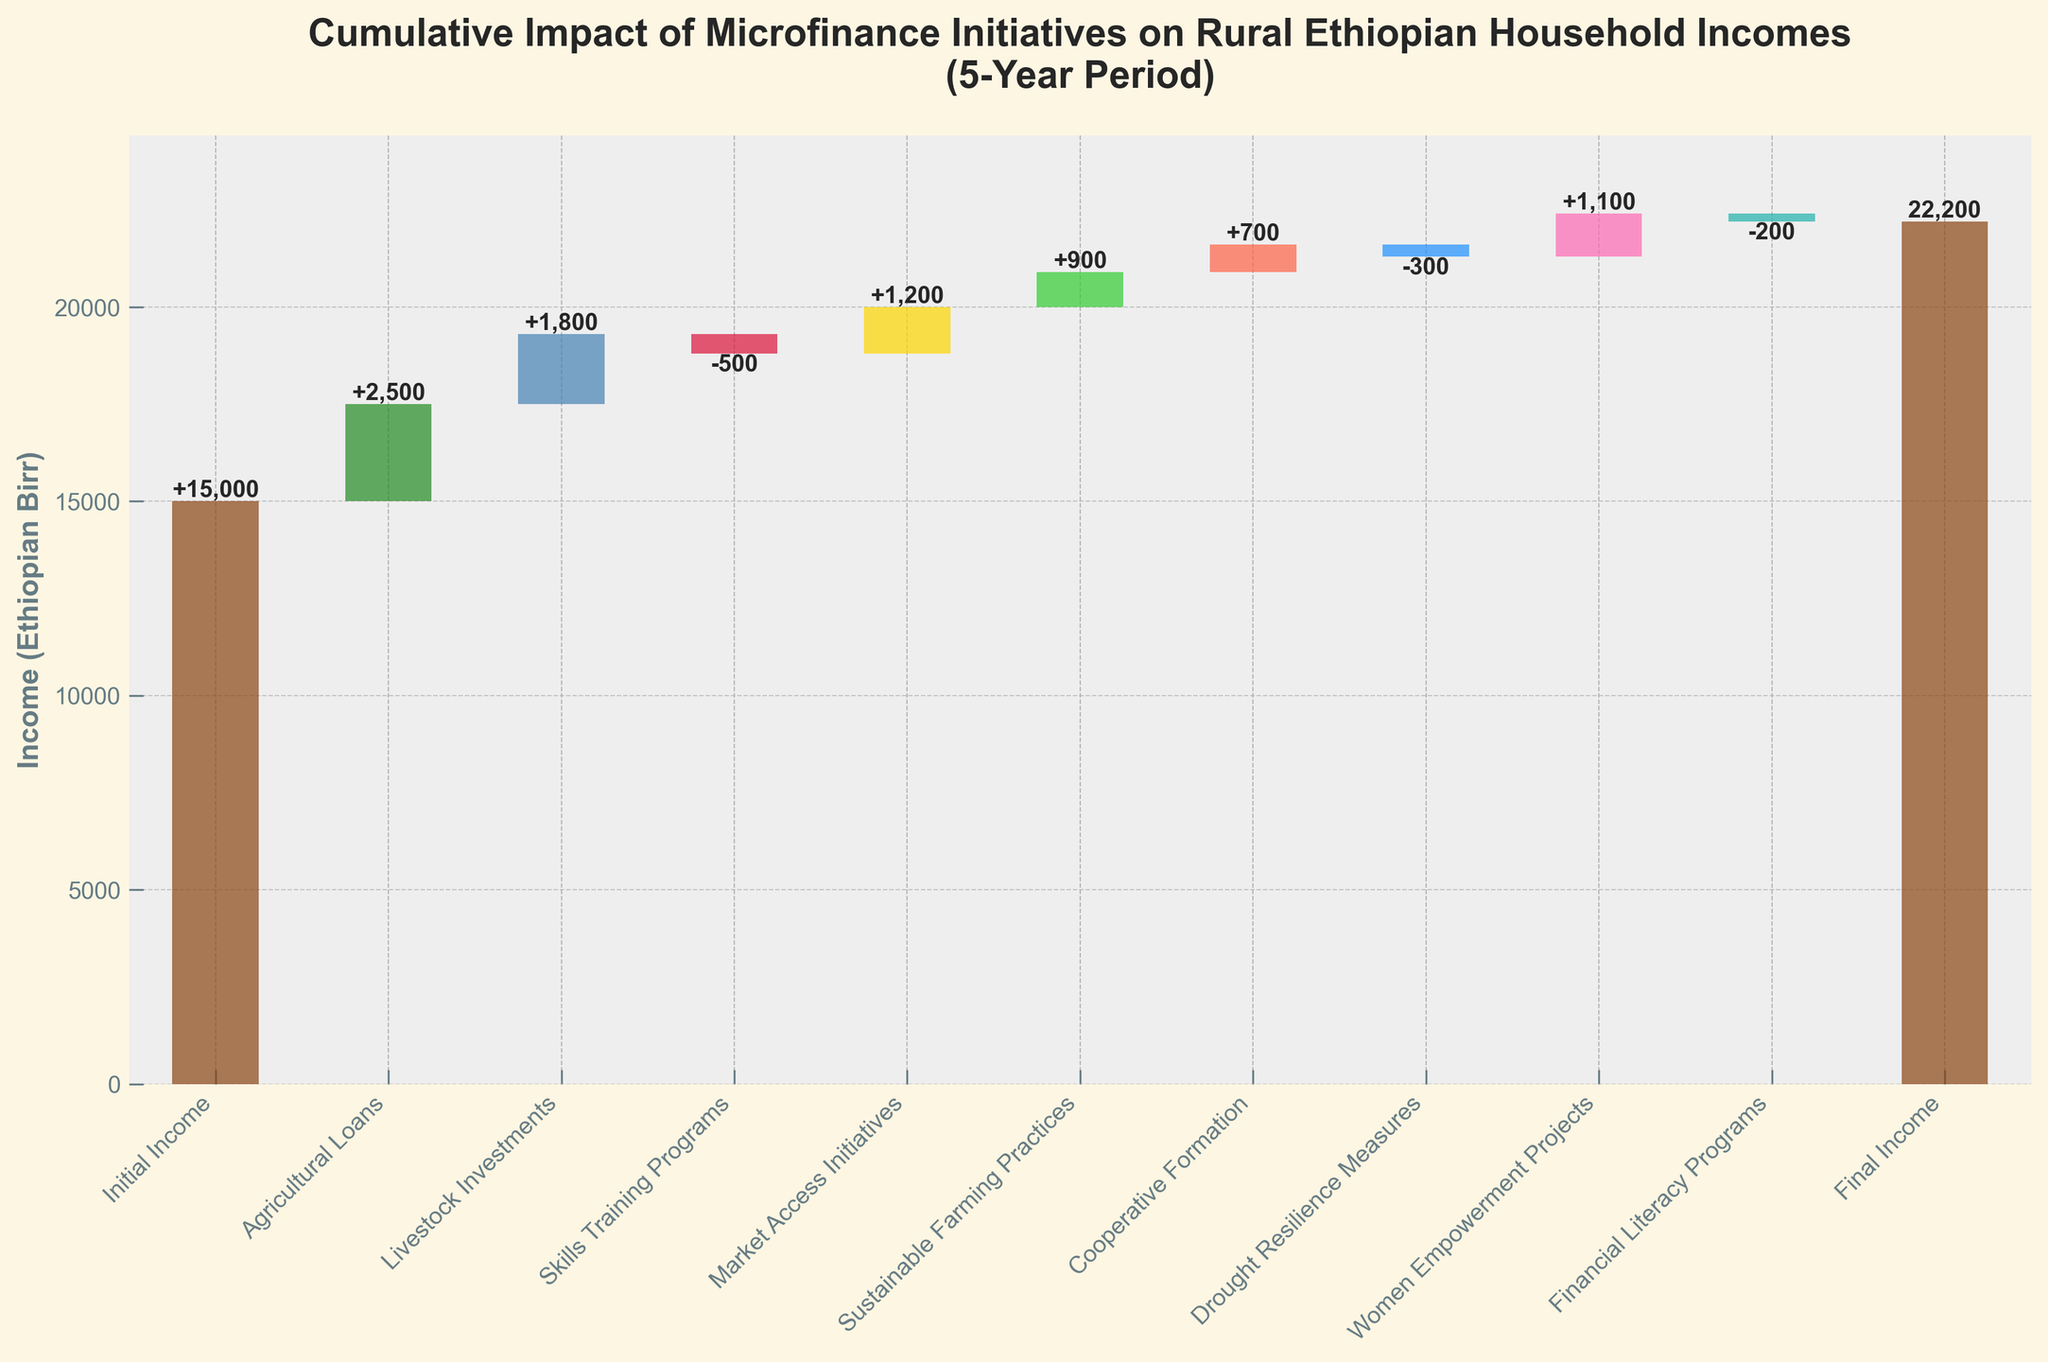Which category contributed the most to the income increase? To find the category that contributed the most, we compare the positive impacts. Agricultural Loans provided the largest positive value of 2500.
Answer: Agricultural Loans What is the total positive impact on the household income? Sum up all positive values: 2500 + 1800 + 1200 + 900 + 700 + 1100 = 8200.
Answer: 8200 What is the net impact of all initiatives on the household income? Sum all values except Initial Income: 2500 + 1800 - 500 + 1200 + 900 + 700 - 300 + 1100 - 200 = 8200.
Answer: 8200 How much was the initial household income before any initiatives? The figure states the Initial Income value directly at the beginning.
Answer: 15000 How much does the Final Income compare to the Initial Income? Subtract Initial Income from Final Income: 22200 - 15000 = 7200.
Answer: 7200 Which initiatives had a negative impact on the household income? Identify all categories with negative values: Skills Training Programs (-500), Drought Resilience Measures (-300), Financial Literacy Programs (-200).
Answer: Skills Training Programs, Drought Resilience Measures, Financial Literacy Programs How did Women's Empowerment Projects impact household income? The value for Women's Empowerment Projects is explicitly stated as a positive impact of 1100.
Answer: 1100 Which initiative had the least positive impact? Compare the positive values: Sustainable Farming Practices (900) has the smallest positive impact among them.
Answer: Sustainable Farming Practices Did the market access initiatives have a positive or negative impact on income? The figure shows Market Access Initiatives had a positive impact with a value of 1200.
Answer: Positive Considering both negative and positive impacts, what is the cumulative effect of microfinance initiatives excluding the initial and final incomes? Starting from 0, add all positive impacts and subtract negatives: 2500 + 1800 - 500 + 1200 + 900 + 700 - 300 + 1100 - 200 = 8200.
Answer: 8200 